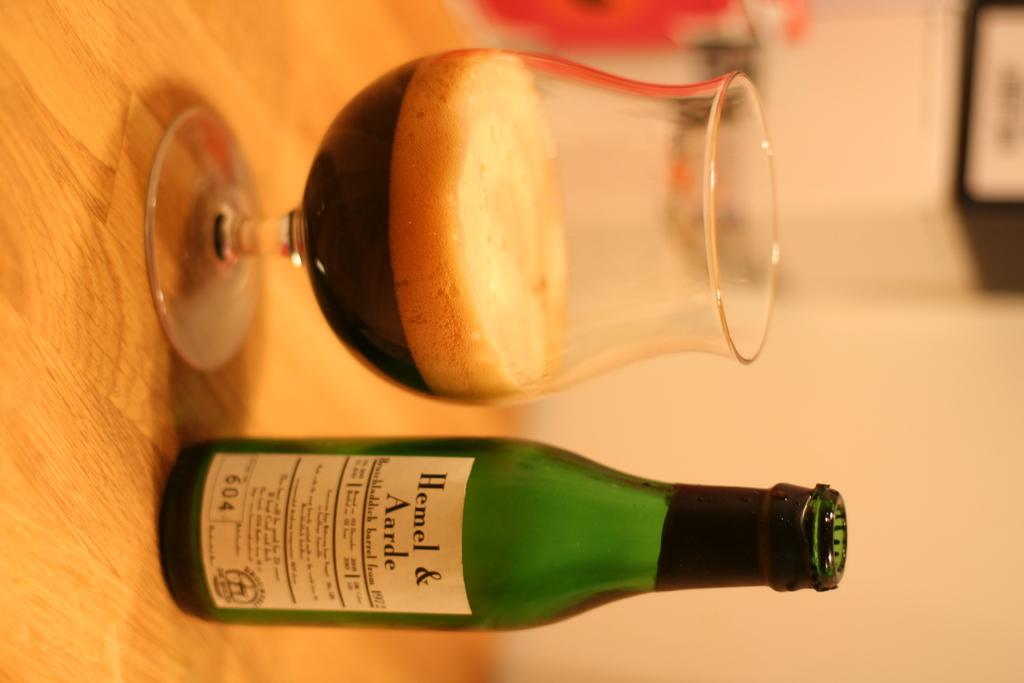<image>
Create a compact narrative representing the image presented. Bottle of hemel and aarde with a glass half empty on a table 